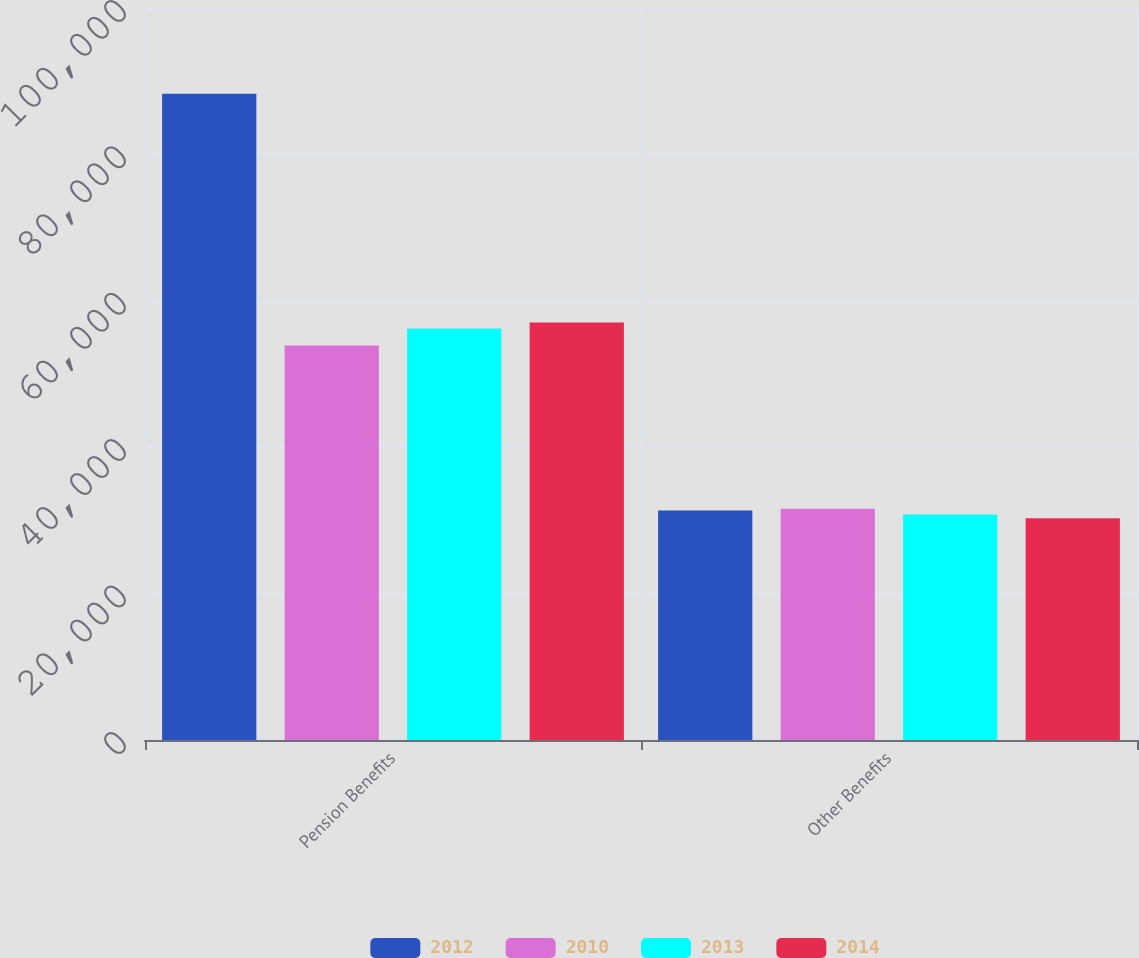Convert chart. <chart><loc_0><loc_0><loc_500><loc_500><stacked_bar_chart><ecel><fcel>Pension Benefits<fcel>Other Benefits<nl><fcel>2012<fcel>88271<fcel>31368<nl><fcel>2010<fcel>53902<fcel>31584<nl><fcel>2013<fcel>56217<fcel>30802<nl><fcel>2014<fcel>57035<fcel>30298<nl></chart> 